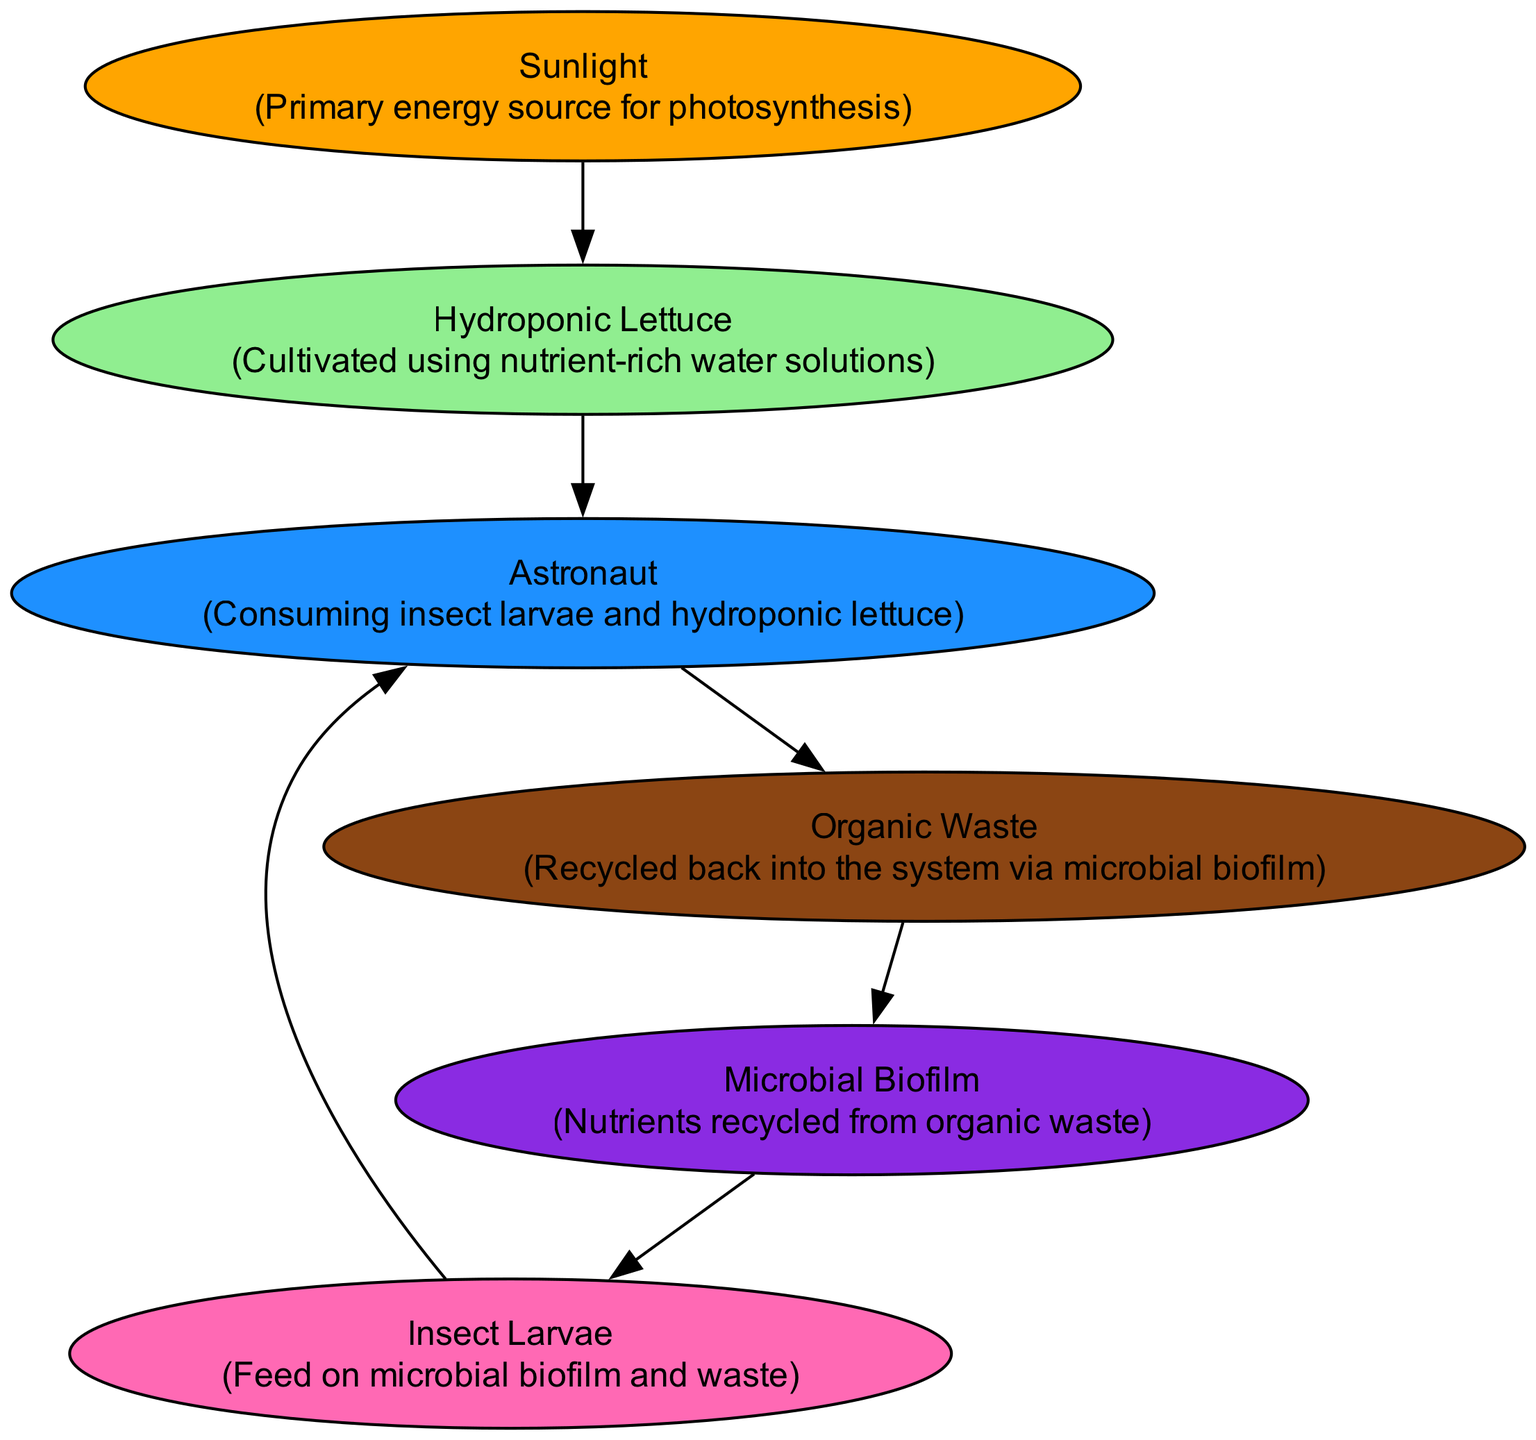What is the primary energy source in the food chain? The diagram indicates that "Sunlight" is the primary energy source for photosynthesis, which is the starting point of the food chain.
Answer: Sunlight How many nodes are present in the diagram? By counting each unique element that represents a part of the food chain, we find a total of six nodes: Sunlight, Hydroponic Lettuce, Microbial Biofilm, Insect Larvae, Astronaut, and Organic Waste.
Answer: 6 What do insect larvae feed on? The diagram illustrates that Insect Larvae feed on Microbial Biofilm, which is part of the recycling process in the ecosystem.
Answer: Microbial Biofilm Which element is consumed by astronauts along with insect larvae? The diagram shows that Astronauts consume both Insect Larvae and Hydroponic Lettuce as part of their diet, indicating a dual source of nutrition.
Answer: Hydroponic Lettuce What role does organic waste play in the food chain? According to the diagram, Organic Waste is recycled back into the system via Microbial Biofilm, contributing to nutrient cycling within the ecosystem.
Answer: Recycled back into the system Which element serves as a nutrient recycler in the ecosystem? The diagram points out that the Microbial Biofilm serves as a nutrient recycler by breaking down organic waste and returning nutrients to the ecosystem.
Answer: Microbial Biofilm What is the flow direction from sunlight to astronauts? The flow starts from Sunlight to Hydroponic Lettuce, then from Hydroponic Lettuce to Astronaut, creating a direct energy pathway.
Answer: Sunlight → Hydroponic Lettuce → Astronaut How does organic waste interact with the microbial biofilm? The diagram illustrates a circular interaction where Organic Waste is converted back into nutrients through the Microbial Biofilm, thus maintaining the cycle.
Answer: Recycles into Microbial Biofilm What color represents hydroponic lettuce in the diagram? In the diagram, Hydroponic Lettuce is represented by a light green color, which visually distinguishes it from the other elements.
Answer: Light green 